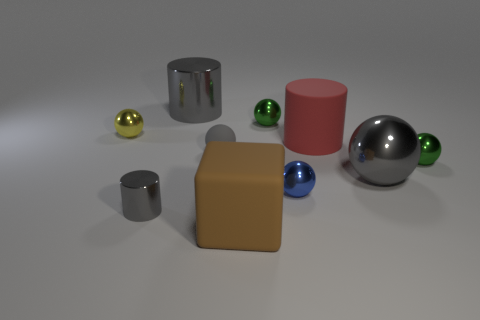What is the material of the large ball that is the same color as the tiny shiny cylinder?
Offer a terse response. Metal. Does the green ball to the left of the red rubber object have the same size as the tiny gray shiny cylinder?
Offer a terse response. Yes. Are there any other blocks that have the same color as the large block?
Your response must be concise. No. There is a cylinder on the right side of the big brown matte thing; are there any blue objects that are to the right of it?
Provide a short and direct response. No. Are there any big brown cubes that have the same material as the small cylinder?
Offer a very short reply. No. What material is the gray thing that is right of the large matte object that is behind the small gray matte thing made of?
Your answer should be very brief. Metal. What is the material of the object that is both to the right of the brown matte cube and in front of the gray metallic ball?
Make the answer very short. Metal. Is the number of small blue metal things that are left of the big brown block the same as the number of tiny rubber balls?
Give a very brief answer. No. How many tiny metal objects are the same shape as the tiny matte thing?
Make the answer very short. 4. There is a brown cube on the left side of the green sphere that is in front of the tiny yellow metal ball that is left of the blue sphere; how big is it?
Provide a short and direct response. Large. 